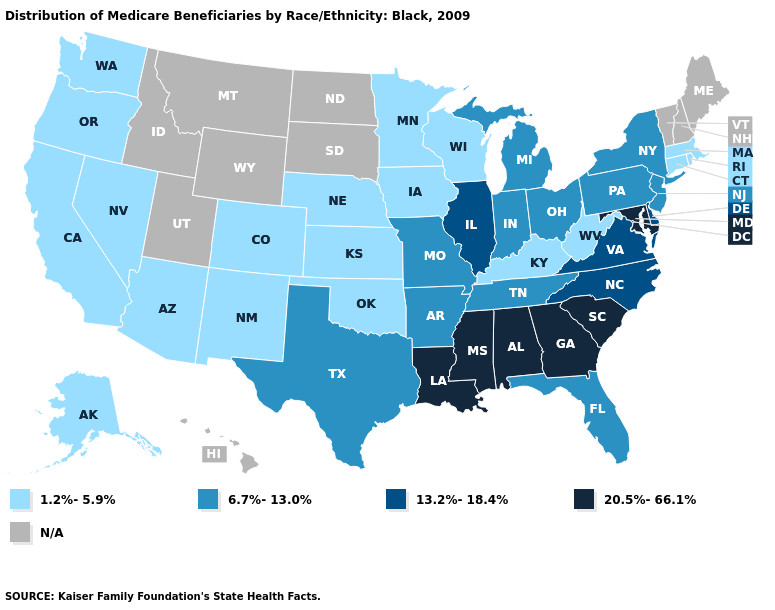How many symbols are there in the legend?
Quick response, please. 5. What is the highest value in the USA?
Give a very brief answer. 20.5%-66.1%. Name the states that have a value in the range 20.5%-66.1%?
Quick response, please. Alabama, Georgia, Louisiana, Maryland, Mississippi, South Carolina. Does the first symbol in the legend represent the smallest category?
Write a very short answer. Yes. What is the value of New Hampshire?
Give a very brief answer. N/A. What is the value of Florida?
Concise answer only. 6.7%-13.0%. Does the first symbol in the legend represent the smallest category?
Be succinct. Yes. What is the value of Colorado?
Concise answer only. 1.2%-5.9%. What is the lowest value in the USA?
Short answer required. 1.2%-5.9%. Does Massachusetts have the lowest value in the Northeast?
Short answer required. Yes. What is the lowest value in states that border Iowa?
Short answer required. 1.2%-5.9%. Among the states that border Kentucky , which have the highest value?
Short answer required. Illinois, Virginia. 